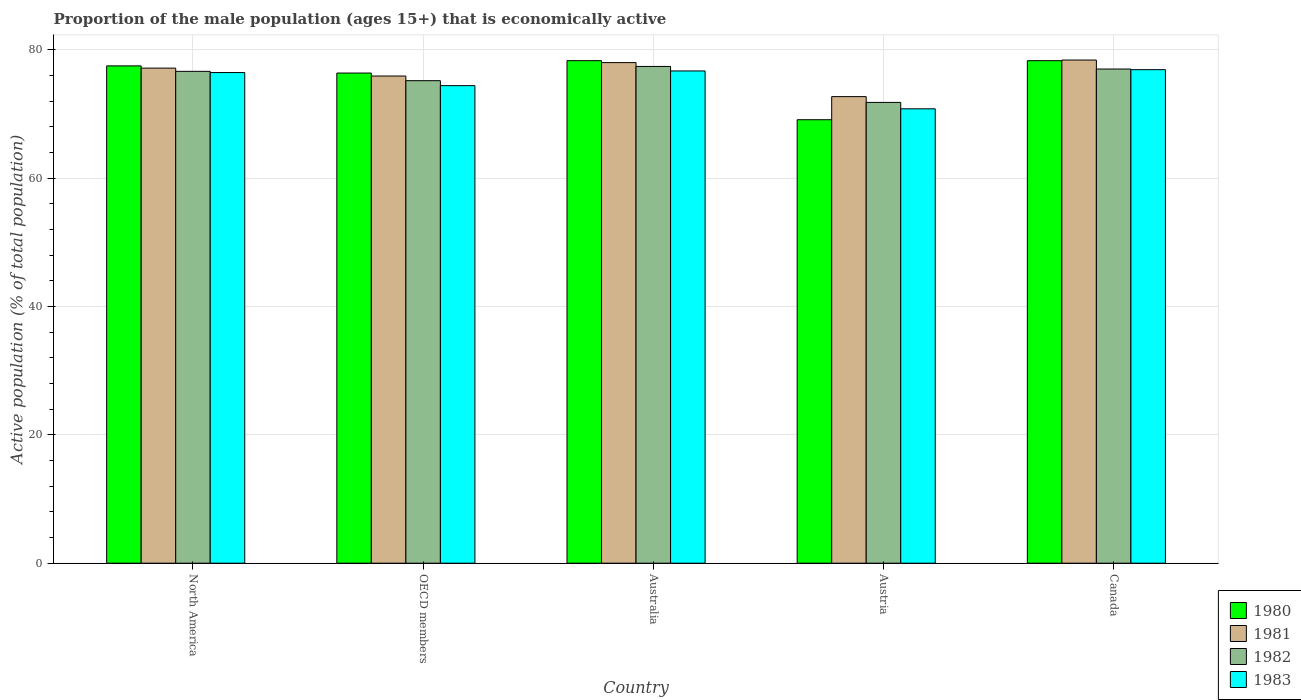How many different coloured bars are there?
Offer a very short reply. 4. How many groups of bars are there?
Offer a terse response. 5. Are the number of bars on each tick of the X-axis equal?
Provide a short and direct response. Yes. How many bars are there on the 5th tick from the right?
Make the answer very short. 4. In how many cases, is the number of bars for a given country not equal to the number of legend labels?
Give a very brief answer. 0. What is the proportion of the male population that is economically active in 1982 in Austria?
Provide a succinct answer. 71.8. Across all countries, what is the maximum proportion of the male population that is economically active in 1981?
Your answer should be compact. 78.4. Across all countries, what is the minimum proportion of the male population that is economically active in 1981?
Keep it short and to the point. 72.7. In which country was the proportion of the male population that is economically active in 1981 minimum?
Provide a succinct answer. Austria. What is the total proportion of the male population that is economically active in 1980 in the graph?
Provide a short and direct response. 379.56. What is the difference between the proportion of the male population that is economically active in 1981 in Australia and that in OECD members?
Keep it short and to the point. 2.09. What is the difference between the proportion of the male population that is economically active in 1982 in Austria and the proportion of the male population that is economically active in 1983 in Australia?
Keep it short and to the point. -4.9. What is the average proportion of the male population that is economically active in 1980 per country?
Your answer should be compact. 75.91. What is the difference between the proportion of the male population that is economically active of/in 1981 and proportion of the male population that is economically active of/in 1982 in Australia?
Your response must be concise. 0.6. What is the ratio of the proportion of the male population that is economically active in 1983 in Austria to that in OECD members?
Ensure brevity in your answer.  0.95. Is the difference between the proportion of the male population that is economically active in 1981 in Austria and North America greater than the difference between the proportion of the male population that is economically active in 1982 in Austria and North America?
Provide a short and direct response. Yes. What is the difference between the highest and the second highest proportion of the male population that is economically active in 1982?
Keep it short and to the point. -0.4. What is the difference between the highest and the lowest proportion of the male population that is economically active in 1981?
Your answer should be very brief. 5.7. What does the 1st bar from the left in OECD members represents?
Provide a succinct answer. 1980. Is it the case that in every country, the sum of the proportion of the male population that is economically active in 1980 and proportion of the male population that is economically active in 1982 is greater than the proportion of the male population that is economically active in 1983?
Offer a very short reply. Yes. Are all the bars in the graph horizontal?
Your answer should be very brief. No. Are the values on the major ticks of Y-axis written in scientific E-notation?
Ensure brevity in your answer.  No. Does the graph contain any zero values?
Your answer should be compact. No. Where does the legend appear in the graph?
Provide a succinct answer. Bottom right. How are the legend labels stacked?
Provide a short and direct response. Vertical. What is the title of the graph?
Provide a succinct answer. Proportion of the male population (ages 15+) that is economically active. What is the label or title of the Y-axis?
Give a very brief answer. Active population (% of total population). What is the Active population (% of total population) in 1980 in North America?
Offer a very short reply. 77.49. What is the Active population (% of total population) of 1981 in North America?
Provide a succinct answer. 77.14. What is the Active population (% of total population) in 1982 in North America?
Offer a terse response. 76.64. What is the Active population (% of total population) in 1983 in North America?
Give a very brief answer. 76.45. What is the Active population (% of total population) in 1980 in OECD members?
Your answer should be compact. 76.37. What is the Active population (% of total population) of 1981 in OECD members?
Provide a succinct answer. 75.91. What is the Active population (% of total population) of 1982 in OECD members?
Your answer should be compact. 75.18. What is the Active population (% of total population) of 1983 in OECD members?
Your answer should be very brief. 74.41. What is the Active population (% of total population) of 1980 in Australia?
Offer a very short reply. 78.3. What is the Active population (% of total population) of 1982 in Australia?
Make the answer very short. 77.4. What is the Active population (% of total population) of 1983 in Australia?
Provide a short and direct response. 76.7. What is the Active population (% of total population) of 1980 in Austria?
Provide a short and direct response. 69.1. What is the Active population (% of total population) of 1981 in Austria?
Ensure brevity in your answer.  72.7. What is the Active population (% of total population) in 1982 in Austria?
Your response must be concise. 71.8. What is the Active population (% of total population) in 1983 in Austria?
Make the answer very short. 70.8. What is the Active population (% of total population) in 1980 in Canada?
Make the answer very short. 78.3. What is the Active population (% of total population) of 1981 in Canada?
Your answer should be compact. 78.4. What is the Active population (% of total population) in 1982 in Canada?
Your answer should be very brief. 77. What is the Active population (% of total population) of 1983 in Canada?
Your answer should be very brief. 76.9. Across all countries, what is the maximum Active population (% of total population) of 1980?
Your answer should be very brief. 78.3. Across all countries, what is the maximum Active population (% of total population) of 1981?
Provide a short and direct response. 78.4. Across all countries, what is the maximum Active population (% of total population) in 1982?
Your answer should be very brief. 77.4. Across all countries, what is the maximum Active population (% of total population) of 1983?
Your response must be concise. 76.9. Across all countries, what is the minimum Active population (% of total population) of 1980?
Ensure brevity in your answer.  69.1. Across all countries, what is the minimum Active population (% of total population) of 1981?
Provide a succinct answer. 72.7. Across all countries, what is the minimum Active population (% of total population) of 1982?
Offer a very short reply. 71.8. Across all countries, what is the minimum Active population (% of total population) in 1983?
Provide a short and direct response. 70.8. What is the total Active population (% of total population) in 1980 in the graph?
Your response must be concise. 379.56. What is the total Active population (% of total population) in 1981 in the graph?
Your response must be concise. 382.15. What is the total Active population (% of total population) in 1982 in the graph?
Offer a terse response. 378.02. What is the total Active population (% of total population) of 1983 in the graph?
Provide a succinct answer. 375.26. What is the difference between the Active population (% of total population) in 1980 in North America and that in OECD members?
Give a very brief answer. 1.12. What is the difference between the Active population (% of total population) of 1981 in North America and that in OECD members?
Keep it short and to the point. 1.23. What is the difference between the Active population (% of total population) in 1982 in North America and that in OECD members?
Keep it short and to the point. 1.46. What is the difference between the Active population (% of total population) of 1983 in North America and that in OECD members?
Ensure brevity in your answer.  2.04. What is the difference between the Active population (% of total population) of 1980 in North America and that in Australia?
Keep it short and to the point. -0.81. What is the difference between the Active population (% of total population) of 1981 in North America and that in Australia?
Make the answer very short. -0.86. What is the difference between the Active population (% of total population) of 1982 in North America and that in Australia?
Provide a short and direct response. -0.76. What is the difference between the Active population (% of total population) of 1983 in North America and that in Australia?
Make the answer very short. -0.25. What is the difference between the Active population (% of total population) of 1980 in North America and that in Austria?
Make the answer very short. 8.39. What is the difference between the Active population (% of total population) in 1981 in North America and that in Austria?
Your response must be concise. 4.44. What is the difference between the Active population (% of total population) in 1982 in North America and that in Austria?
Offer a terse response. 4.84. What is the difference between the Active population (% of total population) in 1983 in North America and that in Austria?
Your answer should be very brief. 5.65. What is the difference between the Active population (% of total population) in 1980 in North America and that in Canada?
Give a very brief answer. -0.81. What is the difference between the Active population (% of total population) in 1981 in North America and that in Canada?
Offer a very short reply. -1.26. What is the difference between the Active population (% of total population) of 1982 in North America and that in Canada?
Give a very brief answer. -0.36. What is the difference between the Active population (% of total population) in 1983 in North America and that in Canada?
Your answer should be very brief. -0.45. What is the difference between the Active population (% of total population) of 1980 in OECD members and that in Australia?
Provide a succinct answer. -1.93. What is the difference between the Active population (% of total population) of 1981 in OECD members and that in Australia?
Offer a terse response. -2.09. What is the difference between the Active population (% of total population) in 1982 in OECD members and that in Australia?
Your answer should be very brief. -2.22. What is the difference between the Active population (% of total population) in 1983 in OECD members and that in Australia?
Provide a succinct answer. -2.29. What is the difference between the Active population (% of total population) of 1980 in OECD members and that in Austria?
Keep it short and to the point. 7.27. What is the difference between the Active population (% of total population) in 1981 in OECD members and that in Austria?
Keep it short and to the point. 3.21. What is the difference between the Active population (% of total population) in 1982 in OECD members and that in Austria?
Your answer should be compact. 3.38. What is the difference between the Active population (% of total population) of 1983 in OECD members and that in Austria?
Offer a very short reply. 3.61. What is the difference between the Active population (% of total population) of 1980 in OECD members and that in Canada?
Your response must be concise. -1.93. What is the difference between the Active population (% of total population) in 1981 in OECD members and that in Canada?
Your response must be concise. -2.49. What is the difference between the Active population (% of total population) of 1982 in OECD members and that in Canada?
Make the answer very short. -1.82. What is the difference between the Active population (% of total population) of 1983 in OECD members and that in Canada?
Offer a very short reply. -2.49. What is the difference between the Active population (% of total population) in 1981 in Australia and that in Austria?
Keep it short and to the point. 5.3. What is the difference between the Active population (% of total population) of 1983 in Australia and that in Austria?
Offer a terse response. 5.9. What is the difference between the Active population (% of total population) of 1982 in Australia and that in Canada?
Make the answer very short. 0.4. What is the difference between the Active population (% of total population) of 1980 in Austria and that in Canada?
Offer a very short reply. -9.2. What is the difference between the Active population (% of total population) of 1982 in Austria and that in Canada?
Make the answer very short. -5.2. What is the difference between the Active population (% of total population) of 1980 in North America and the Active population (% of total population) of 1981 in OECD members?
Provide a short and direct response. 1.58. What is the difference between the Active population (% of total population) of 1980 in North America and the Active population (% of total population) of 1982 in OECD members?
Your response must be concise. 2.31. What is the difference between the Active population (% of total population) of 1980 in North America and the Active population (% of total population) of 1983 in OECD members?
Make the answer very short. 3.08. What is the difference between the Active population (% of total population) in 1981 in North America and the Active population (% of total population) in 1982 in OECD members?
Keep it short and to the point. 1.96. What is the difference between the Active population (% of total population) of 1981 in North America and the Active population (% of total population) of 1983 in OECD members?
Offer a very short reply. 2.73. What is the difference between the Active population (% of total population) of 1982 in North America and the Active population (% of total population) of 1983 in OECD members?
Ensure brevity in your answer.  2.23. What is the difference between the Active population (% of total population) in 1980 in North America and the Active population (% of total population) in 1981 in Australia?
Provide a succinct answer. -0.51. What is the difference between the Active population (% of total population) in 1980 in North America and the Active population (% of total population) in 1982 in Australia?
Ensure brevity in your answer.  0.09. What is the difference between the Active population (% of total population) in 1980 in North America and the Active population (% of total population) in 1983 in Australia?
Your answer should be compact. 0.79. What is the difference between the Active population (% of total population) of 1981 in North America and the Active population (% of total population) of 1982 in Australia?
Keep it short and to the point. -0.26. What is the difference between the Active population (% of total population) of 1981 in North America and the Active population (% of total population) of 1983 in Australia?
Give a very brief answer. 0.44. What is the difference between the Active population (% of total population) of 1982 in North America and the Active population (% of total population) of 1983 in Australia?
Give a very brief answer. -0.06. What is the difference between the Active population (% of total population) of 1980 in North America and the Active population (% of total population) of 1981 in Austria?
Your response must be concise. 4.79. What is the difference between the Active population (% of total population) in 1980 in North America and the Active population (% of total population) in 1982 in Austria?
Give a very brief answer. 5.69. What is the difference between the Active population (% of total population) of 1980 in North America and the Active population (% of total population) of 1983 in Austria?
Give a very brief answer. 6.69. What is the difference between the Active population (% of total population) in 1981 in North America and the Active population (% of total population) in 1982 in Austria?
Offer a terse response. 5.34. What is the difference between the Active population (% of total population) in 1981 in North America and the Active population (% of total population) in 1983 in Austria?
Offer a very short reply. 6.34. What is the difference between the Active population (% of total population) of 1982 in North America and the Active population (% of total population) of 1983 in Austria?
Your answer should be very brief. 5.84. What is the difference between the Active population (% of total population) in 1980 in North America and the Active population (% of total population) in 1981 in Canada?
Your answer should be very brief. -0.91. What is the difference between the Active population (% of total population) in 1980 in North America and the Active population (% of total population) in 1982 in Canada?
Keep it short and to the point. 0.49. What is the difference between the Active population (% of total population) of 1980 in North America and the Active population (% of total population) of 1983 in Canada?
Provide a succinct answer. 0.59. What is the difference between the Active population (% of total population) in 1981 in North America and the Active population (% of total population) in 1982 in Canada?
Offer a terse response. 0.14. What is the difference between the Active population (% of total population) in 1981 in North America and the Active population (% of total population) in 1983 in Canada?
Ensure brevity in your answer.  0.24. What is the difference between the Active population (% of total population) in 1982 in North America and the Active population (% of total population) in 1983 in Canada?
Provide a short and direct response. -0.26. What is the difference between the Active population (% of total population) in 1980 in OECD members and the Active population (% of total population) in 1981 in Australia?
Your answer should be compact. -1.63. What is the difference between the Active population (% of total population) in 1980 in OECD members and the Active population (% of total population) in 1982 in Australia?
Offer a terse response. -1.03. What is the difference between the Active population (% of total population) in 1980 in OECD members and the Active population (% of total population) in 1983 in Australia?
Your response must be concise. -0.33. What is the difference between the Active population (% of total population) of 1981 in OECD members and the Active population (% of total population) of 1982 in Australia?
Make the answer very short. -1.49. What is the difference between the Active population (% of total population) in 1981 in OECD members and the Active population (% of total population) in 1983 in Australia?
Keep it short and to the point. -0.79. What is the difference between the Active population (% of total population) of 1982 in OECD members and the Active population (% of total population) of 1983 in Australia?
Offer a terse response. -1.52. What is the difference between the Active population (% of total population) of 1980 in OECD members and the Active population (% of total population) of 1981 in Austria?
Keep it short and to the point. 3.67. What is the difference between the Active population (% of total population) in 1980 in OECD members and the Active population (% of total population) in 1982 in Austria?
Provide a succinct answer. 4.57. What is the difference between the Active population (% of total population) in 1980 in OECD members and the Active population (% of total population) in 1983 in Austria?
Offer a terse response. 5.57. What is the difference between the Active population (% of total population) of 1981 in OECD members and the Active population (% of total population) of 1982 in Austria?
Offer a terse response. 4.11. What is the difference between the Active population (% of total population) in 1981 in OECD members and the Active population (% of total population) in 1983 in Austria?
Provide a short and direct response. 5.11. What is the difference between the Active population (% of total population) of 1982 in OECD members and the Active population (% of total population) of 1983 in Austria?
Give a very brief answer. 4.38. What is the difference between the Active population (% of total population) in 1980 in OECD members and the Active population (% of total population) in 1981 in Canada?
Your response must be concise. -2.03. What is the difference between the Active population (% of total population) in 1980 in OECD members and the Active population (% of total population) in 1982 in Canada?
Make the answer very short. -0.63. What is the difference between the Active population (% of total population) in 1980 in OECD members and the Active population (% of total population) in 1983 in Canada?
Keep it short and to the point. -0.53. What is the difference between the Active population (% of total population) of 1981 in OECD members and the Active population (% of total population) of 1982 in Canada?
Your answer should be very brief. -1.09. What is the difference between the Active population (% of total population) in 1981 in OECD members and the Active population (% of total population) in 1983 in Canada?
Your answer should be compact. -0.99. What is the difference between the Active population (% of total population) in 1982 in OECD members and the Active population (% of total population) in 1983 in Canada?
Your answer should be compact. -1.72. What is the difference between the Active population (% of total population) of 1981 in Australia and the Active population (% of total population) of 1982 in Austria?
Ensure brevity in your answer.  6.2. What is the difference between the Active population (% of total population) of 1981 in Australia and the Active population (% of total population) of 1983 in Austria?
Keep it short and to the point. 7.2. What is the difference between the Active population (% of total population) in 1982 in Australia and the Active population (% of total population) in 1983 in Austria?
Your answer should be compact. 6.6. What is the difference between the Active population (% of total population) of 1980 in Australia and the Active population (% of total population) of 1982 in Canada?
Give a very brief answer. 1.3. What is the difference between the Active population (% of total population) in 1981 in Australia and the Active population (% of total population) in 1983 in Canada?
Your answer should be very brief. 1.1. What is the difference between the Active population (% of total population) in 1980 in Austria and the Active population (% of total population) in 1981 in Canada?
Your answer should be very brief. -9.3. What is the difference between the Active population (% of total population) of 1981 in Austria and the Active population (% of total population) of 1983 in Canada?
Ensure brevity in your answer.  -4.2. What is the average Active population (% of total population) in 1980 per country?
Ensure brevity in your answer.  75.91. What is the average Active population (% of total population) in 1981 per country?
Your response must be concise. 76.43. What is the average Active population (% of total population) in 1982 per country?
Keep it short and to the point. 75.6. What is the average Active population (% of total population) of 1983 per country?
Give a very brief answer. 75.05. What is the difference between the Active population (% of total population) of 1980 and Active population (% of total population) of 1981 in North America?
Give a very brief answer. 0.35. What is the difference between the Active population (% of total population) in 1980 and Active population (% of total population) in 1982 in North America?
Offer a very short reply. 0.85. What is the difference between the Active population (% of total population) in 1980 and Active population (% of total population) in 1983 in North America?
Your answer should be compact. 1.04. What is the difference between the Active population (% of total population) in 1981 and Active population (% of total population) in 1982 in North America?
Your answer should be very brief. 0.5. What is the difference between the Active population (% of total population) of 1981 and Active population (% of total population) of 1983 in North America?
Provide a succinct answer. 0.69. What is the difference between the Active population (% of total population) of 1982 and Active population (% of total population) of 1983 in North America?
Your answer should be very brief. 0.19. What is the difference between the Active population (% of total population) of 1980 and Active population (% of total population) of 1981 in OECD members?
Your answer should be very brief. 0.46. What is the difference between the Active population (% of total population) of 1980 and Active population (% of total population) of 1982 in OECD members?
Ensure brevity in your answer.  1.19. What is the difference between the Active population (% of total population) in 1980 and Active population (% of total population) in 1983 in OECD members?
Provide a succinct answer. 1.96. What is the difference between the Active population (% of total population) in 1981 and Active population (% of total population) in 1982 in OECD members?
Make the answer very short. 0.73. What is the difference between the Active population (% of total population) in 1981 and Active population (% of total population) in 1983 in OECD members?
Provide a succinct answer. 1.5. What is the difference between the Active population (% of total population) of 1982 and Active population (% of total population) of 1983 in OECD members?
Ensure brevity in your answer.  0.77. What is the difference between the Active population (% of total population) in 1982 and Active population (% of total population) in 1983 in Australia?
Provide a succinct answer. 0.7. What is the difference between the Active population (% of total population) of 1980 and Active population (% of total population) of 1981 in Austria?
Give a very brief answer. -3.6. What is the difference between the Active population (% of total population) in 1980 and Active population (% of total population) in 1982 in Austria?
Offer a terse response. -2.7. What is the difference between the Active population (% of total population) in 1980 and Active population (% of total population) in 1983 in Austria?
Keep it short and to the point. -1.7. What is the difference between the Active population (% of total population) of 1982 and Active population (% of total population) of 1983 in Austria?
Your answer should be compact. 1. What is the difference between the Active population (% of total population) of 1980 and Active population (% of total population) of 1981 in Canada?
Offer a terse response. -0.1. What is the difference between the Active population (% of total population) of 1980 and Active population (% of total population) of 1982 in Canada?
Make the answer very short. 1.3. What is the difference between the Active population (% of total population) of 1980 and Active population (% of total population) of 1983 in Canada?
Your answer should be compact. 1.4. What is the difference between the Active population (% of total population) in 1981 and Active population (% of total population) in 1982 in Canada?
Ensure brevity in your answer.  1.4. What is the ratio of the Active population (% of total population) in 1980 in North America to that in OECD members?
Your answer should be compact. 1.01. What is the ratio of the Active population (% of total population) of 1981 in North America to that in OECD members?
Provide a succinct answer. 1.02. What is the ratio of the Active population (% of total population) in 1982 in North America to that in OECD members?
Your answer should be compact. 1.02. What is the ratio of the Active population (% of total population) of 1983 in North America to that in OECD members?
Your response must be concise. 1.03. What is the ratio of the Active population (% of total population) in 1980 in North America to that in Australia?
Make the answer very short. 0.99. What is the ratio of the Active population (% of total population) of 1981 in North America to that in Australia?
Ensure brevity in your answer.  0.99. What is the ratio of the Active population (% of total population) in 1982 in North America to that in Australia?
Offer a very short reply. 0.99. What is the ratio of the Active population (% of total population) of 1980 in North America to that in Austria?
Keep it short and to the point. 1.12. What is the ratio of the Active population (% of total population) in 1981 in North America to that in Austria?
Ensure brevity in your answer.  1.06. What is the ratio of the Active population (% of total population) in 1982 in North America to that in Austria?
Offer a very short reply. 1.07. What is the ratio of the Active population (% of total population) in 1983 in North America to that in Austria?
Give a very brief answer. 1.08. What is the ratio of the Active population (% of total population) in 1981 in North America to that in Canada?
Provide a succinct answer. 0.98. What is the ratio of the Active population (% of total population) in 1980 in OECD members to that in Australia?
Your answer should be very brief. 0.98. What is the ratio of the Active population (% of total population) of 1981 in OECD members to that in Australia?
Offer a very short reply. 0.97. What is the ratio of the Active population (% of total population) of 1982 in OECD members to that in Australia?
Offer a very short reply. 0.97. What is the ratio of the Active population (% of total population) of 1983 in OECD members to that in Australia?
Give a very brief answer. 0.97. What is the ratio of the Active population (% of total population) in 1980 in OECD members to that in Austria?
Provide a succinct answer. 1.11. What is the ratio of the Active population (% of total population) in 1981 in OECD members to that in Austria?
Keep it short and to the point. 1.04. What is the ratio of the Active population (% of total population) in 1982 in OECD members to that in Austria?
Your answer should be very brief. 1.05. What is the ratio of the Active population (% of total population) in 1983 in OECD members to that in Austria?
Give a very brief answer. 1.05. What is the ratio of the Active population (% of total population) in 1980 in OECD members to that in Canada?
Make the answer very short. 0.98. What is the ratio of the Active population (% of total population) in 1981 in OECD members to that in Canada?
Give a very brief answer. 0.97. What is the ratio of the Active population (% of total population) in 1982 in OECD members to that in Canada?
Keep it short and to the point. 0.98. What is the ratio of the Active population (% of total population) of 1983 in OECD members to that in Canada?
Provide a succinct answer. 0.97. What is the ratio of the Active population (% of total population) of 1980 in Australia to that in Austria?
Your answer should be very brief. 1.13. What is the ratio of the Active population (% of total population) of 1981 in Australia to that in Austria?
Ensure brevity in your answer.  1.07. What is the ratio of the Active population (% of total population) of 1982 in Australia to that in Austria?
Provide a short and direct response. 1.08. What is the ratio of the Active population (% of total population) of 1983 in Australia to that in Austria?
Offer a terse response. 1.08. What is the ratio of the Active population (% of total population) in 1980 in Australia to that in Canada?
Keep it short and to the point. 1. What is the ratio of the Active population (% of total population) in 1980 in Austria to that in Canada?
Your answer should be very brief. 0.88. What is the ratio of the Active population (% of total population) in 1981 in Austria to that in Canada?
Give a very brief answer. 0.93. What is the ratio of the Active population (% of total population) of 1982 in Austria to that in Canada?
Your response must be concise. 0.93. What is the ratio of the Active population (% of total population) of 1983 in Austria to that in Canada?
Provide a short and direct response. 0.92. What is the difference between the highest and the second highest Active population (% of total population) of 1981?
Your answer should be very brief. 0.4. What is the difference between the highest and the second highest Active population (% of total population) of 1982?
Your response must be concise. 0.4. What is the difference between the highest and the lowest Active population (% of total population) of 1982?
Offer a terse response. 5.6. What is the difference between the highest and the lowest Active population (% of total population) of 1983?
Give a very brief answer. 6.1. 